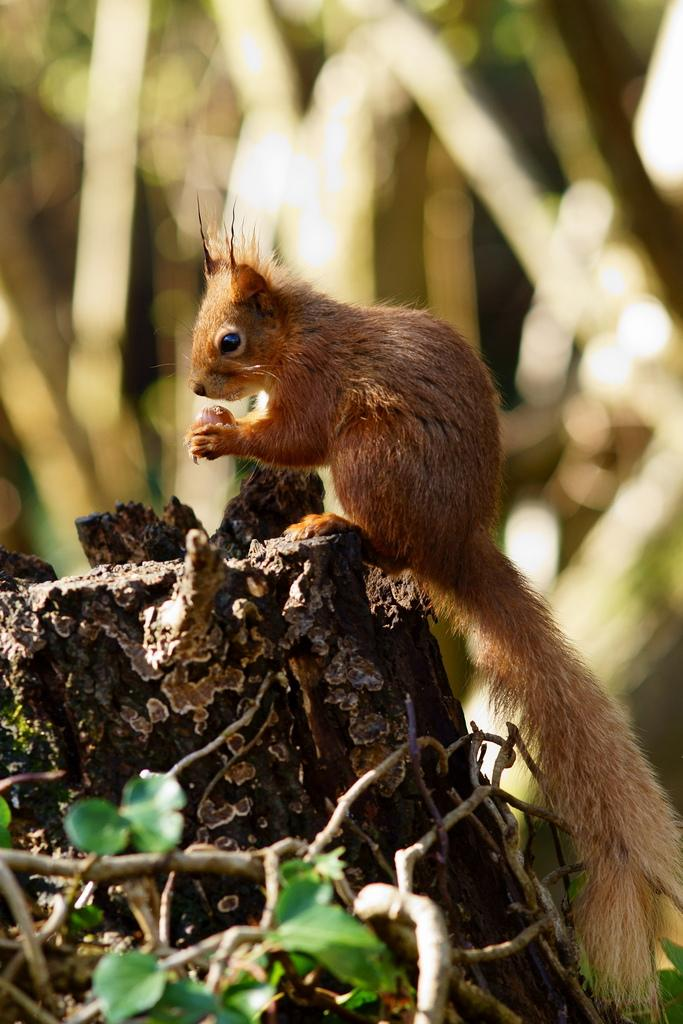What type of animal is in the image? There is a chipmunk in the image. What is the chipmunk resting on? The chipmunk is on a wooden object. Can you describe the background of the image? The background of the image is blurry. What type of tax is being discussed in the image? There is no discussion of tax in the image; it features a chipmunk on a wooden object with a blurry background. 